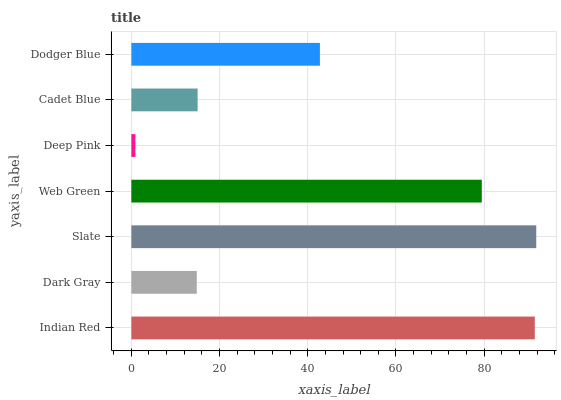Is Deep Pink the minimum?
Answer yes or no. Yes. Is Slate the maximum?
Answer yes or no. Yes. Is Dark Gray the minimum?
Answer yes or no. No. Is Dark Gray the maximum?
Answer yes or no. No. Is Indian Red greater than Dark Gray?
Answer yes or no. Yes. Is Dark Gray less than Indian Red?
Answer yes or no. Yes. Is Dark Gray greater than Indian Red?
Answer yes or no. No. Is Indian Red less than Dark Gray?
Answer yes or no. No. Is Dodger Blue the high median?
Answer yes or no. Yes. Is Dodger Blue the low median?
Answer yes or no. Yes. Is Cadet Blue the high median?
Answer yes or no. No. Is Web Green the low median?
Answer yes or no. No. 